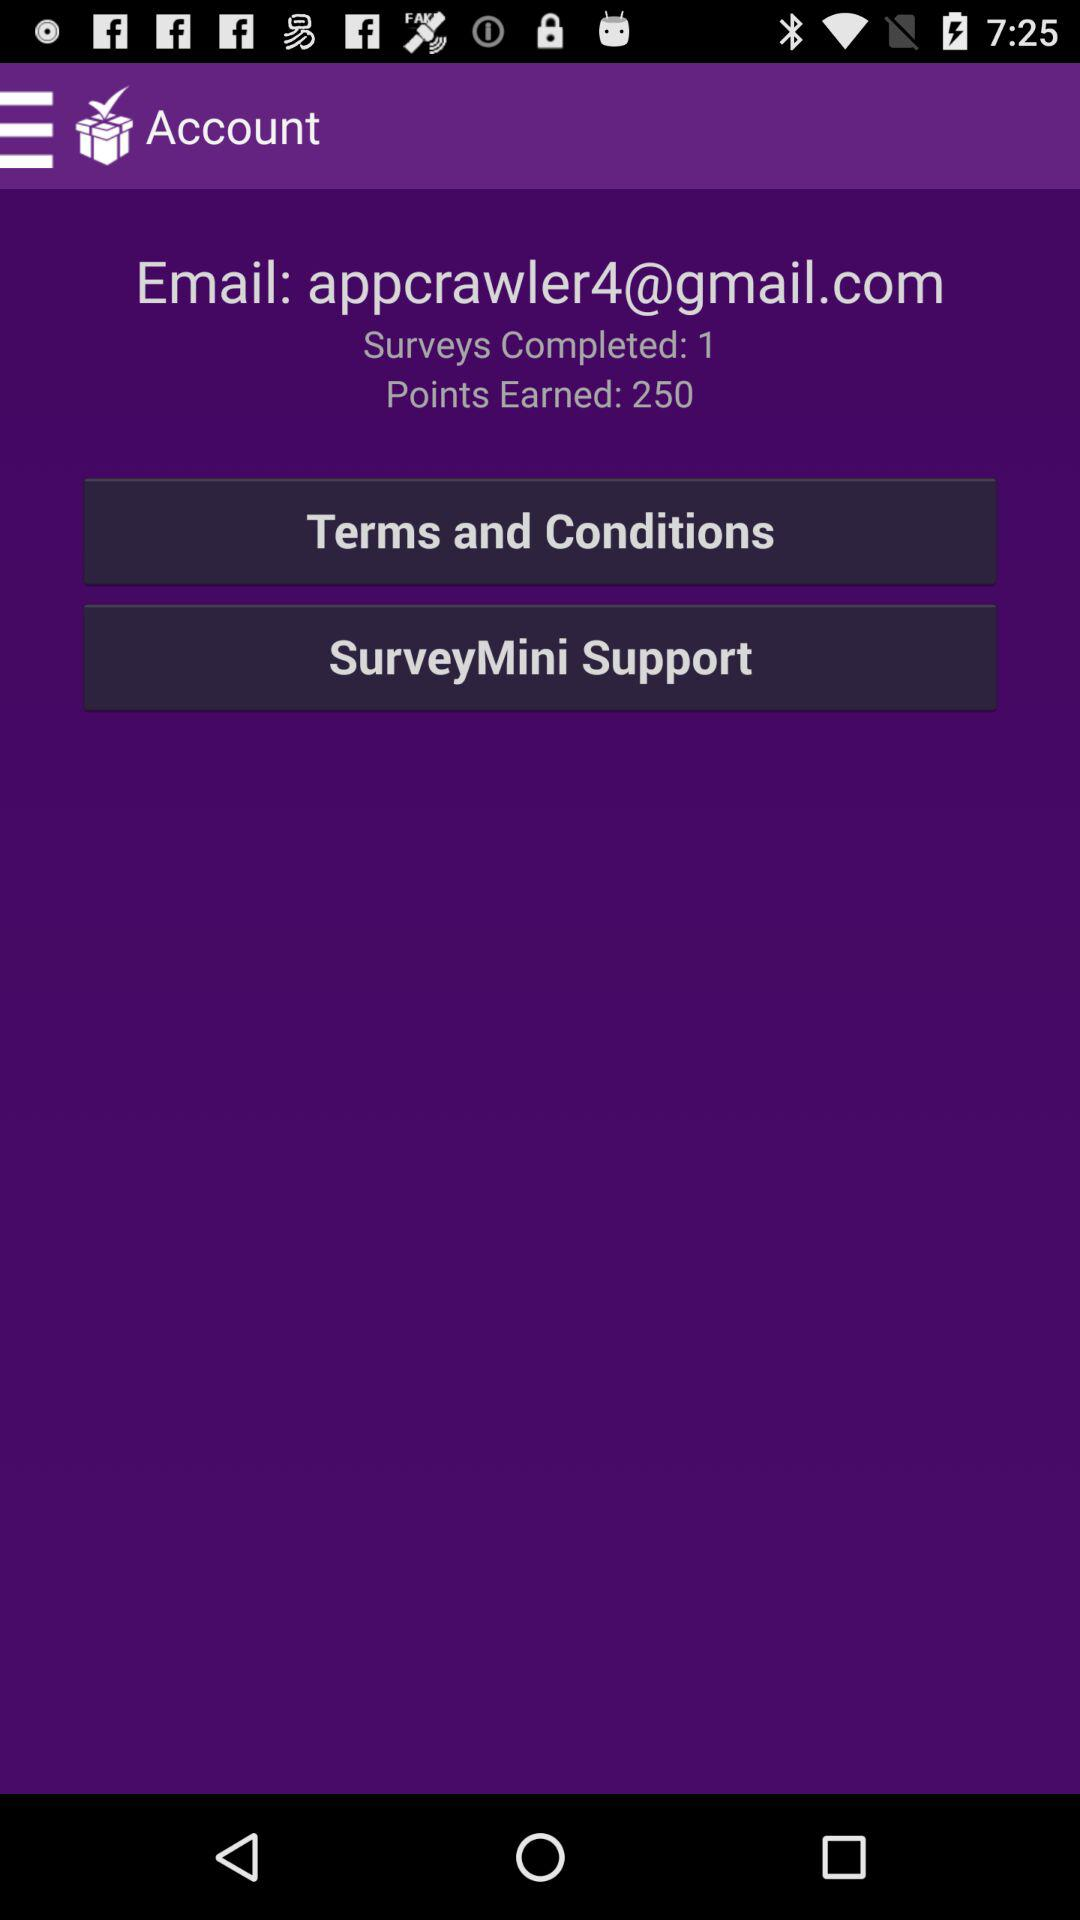What are the earned points? There are 250 earned points. 